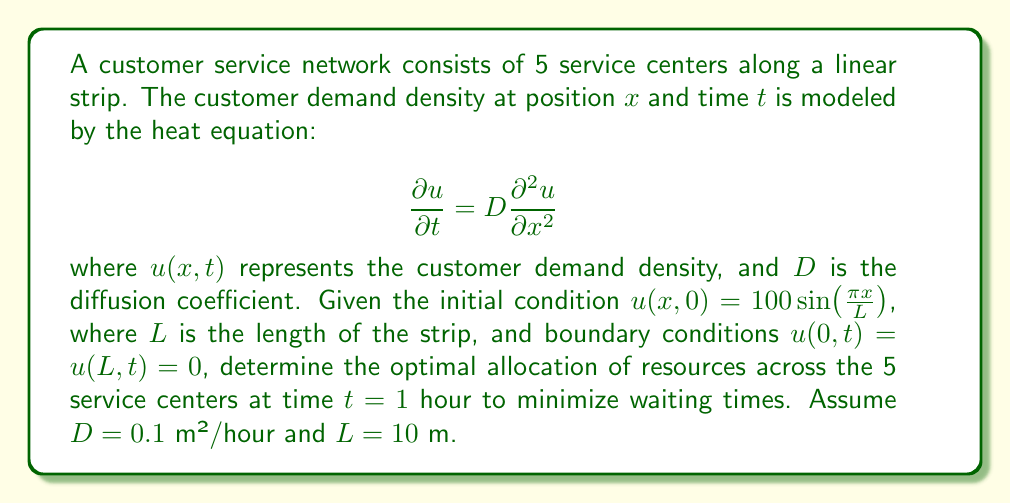Could you help me with this problem? To solve this problem, we need to follow these steps:

1) First, we need to solve the heat equation with the given initial and boundary conditions. The solution to this problem is of the form:

   $$u(x,t) = A e^{-\alpha t} \sin(\pi x/L)$$

   where $A$ and $\alpha$ are constants to be determined.

2) Substituting this into the heat equation:

   $$-\alpha A e^{-\alpha t} \sin(\pi x/L) = D A e^{-\alpha t} (-\pi^2/L^2) \sin(\pi x/L)$$

   This gives us: $\alpha = D\pi^2/L^2 = 0.1 \pi^2 / 100 = \pi^2/1000$

3) From the initial condition, we can determine $A$:

   $$u(x,0) = A \sin(\pi x/L) = 100 \sin(\pi x/L)$$

   Therefore, $A = 100$

4) So, the solution is:

   $$u(x,t) = 100 e^{-\pi^2 t/1000} \sin(\pi x/10)$$

5) At $t = 1$ hour, the demand distribution is:

   $$u(x,1) = 100 e^{-\pi^2/1000} \sin(\pi x/10) \approx 90.3 \sin(\pi x/10)$$

6) To optimize resource allocation, we should distribute resources proportionally to the demand at each location. The 5 service centers are likely located at $x = 1, 3, 5, 7,$ and $9$ meters.

7) The demand at these locations at $t = 1$ hour is:

   $u(1,1) \approx 90.3 \sin(\pi/10) \approx 27.9$
   $u(3,1) \approx 90.3 \sin(3\pi/10) \approx 73.7$
   $u(5,1) \approx 90.3 \sin(\pi/2) \approx 90.3$
   $u(7,1) \approx 90.3 \sin(7\pi/10) \approx 73.7$
   $u(9,1) \approx 90.3 \sin(9\pi/10) \approx 27.9$

8) The total demand is the sum of these: 293.5

9) The optimal resource allocation percentages are these demands divided by the total:

   Center 1 (x=1m): 27.9 / 293.5 ≈ 9.5%
   Center 2 (x=3m): 73.7 / 293.5 ≈ 25.1%
   Center 3 (x=5m): 90.3 / 293.5 ≈ 30.8%
   Center 4 (x=7m): 73.7 / 293.5 ≈ 25.1%
   Center 5 (x=9m): 27.9 / 293.5 ≈ 9.5%
Answer: The optimal resource allocation across the 5 service centers at $t = 1$ hour is approximately:
Center 1: 9.5%
Center 2: 25.1%
Center 3: 30.8%
Center 4: 25.1%
Center 5: 9.5% 